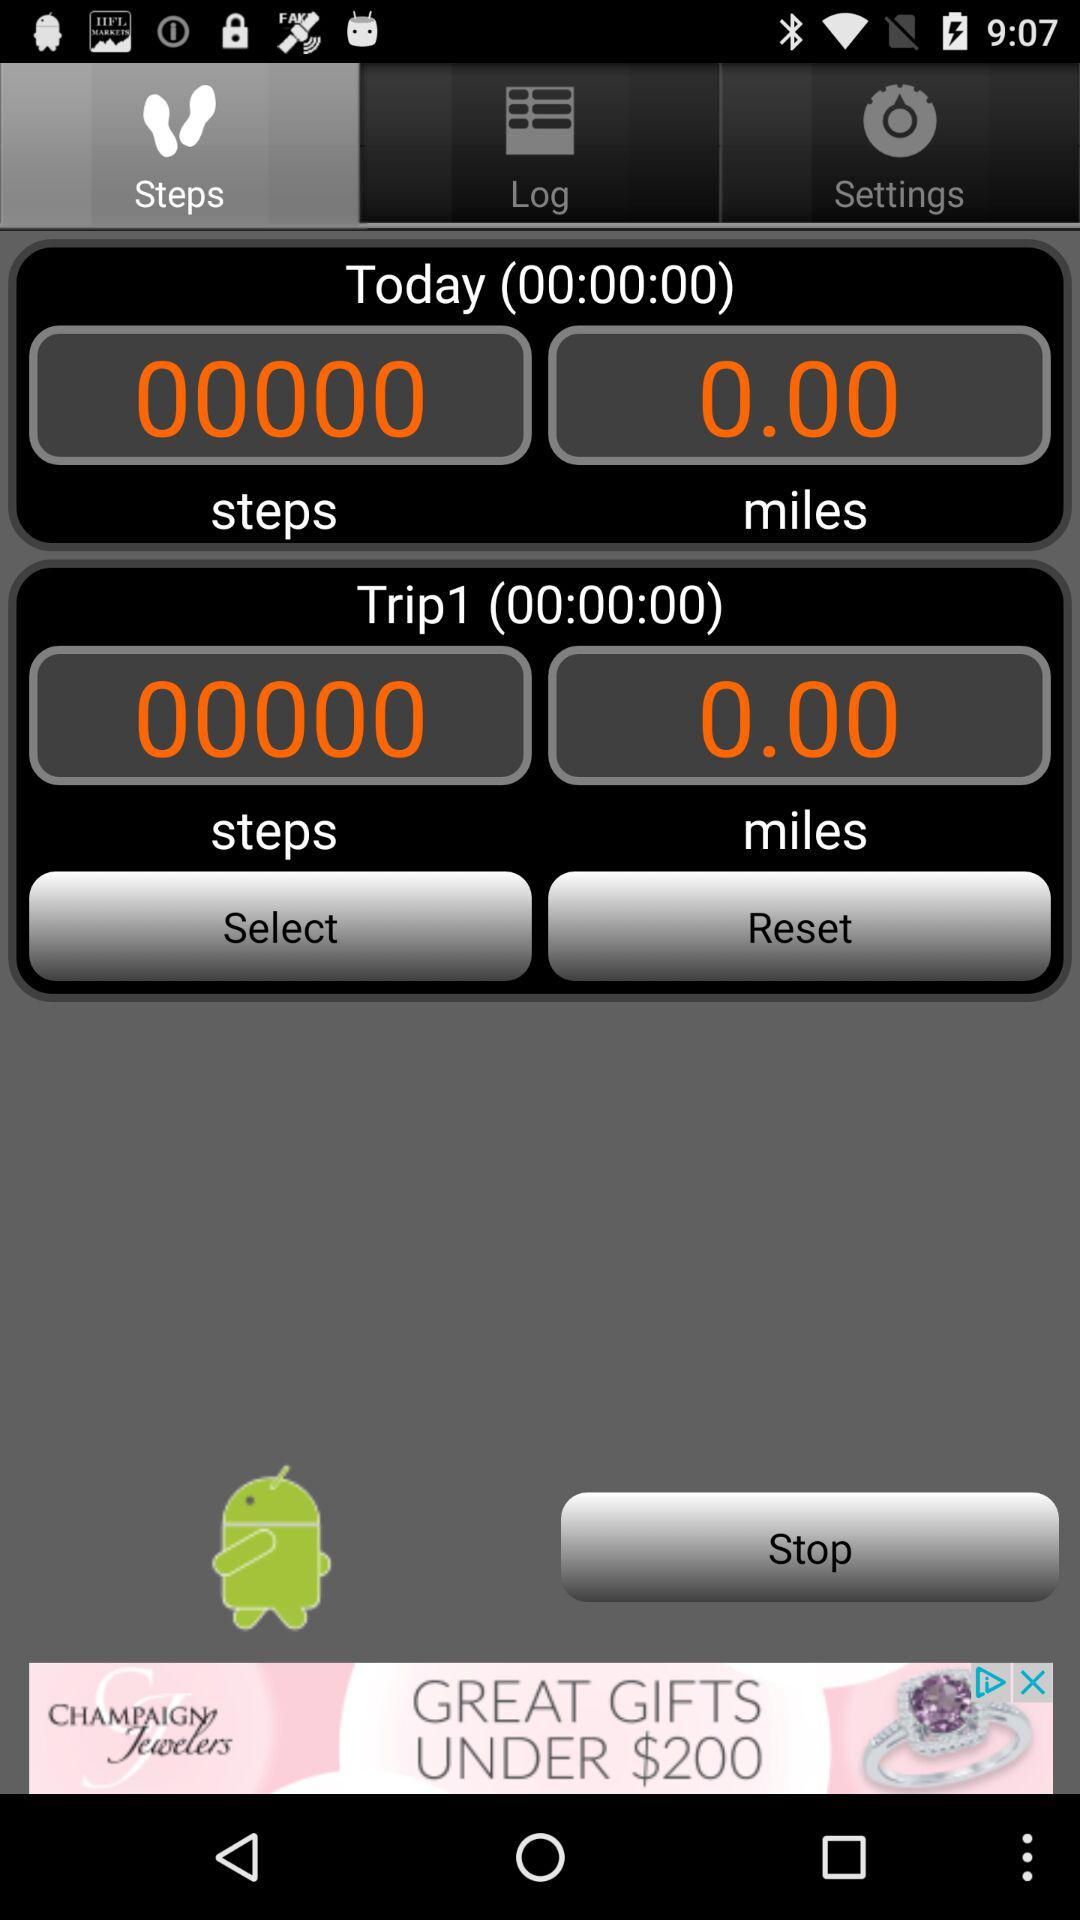What distance was covered today? The covered distance was 0 miles. 